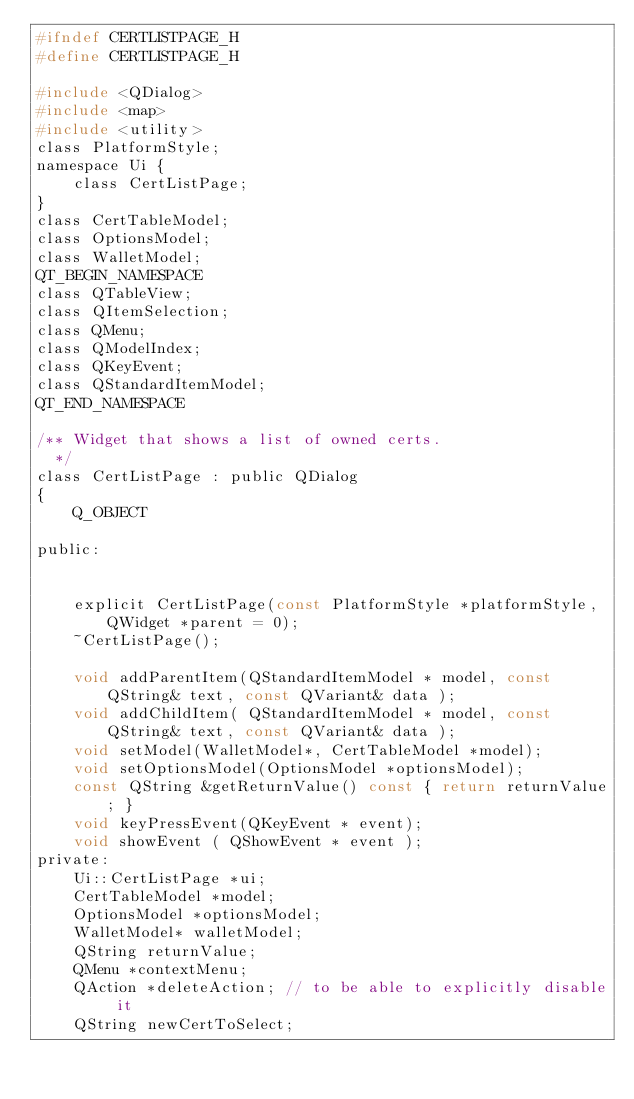<code> <loc_0><loc_0><loc_500><loc_500><_C_>#ifndef CERTLISTPAGE_H
#define CERTLISTPAGE_H

#include <QDialog>
#include <map>
#include <utility>
class PlatformStyle;
namespace Ui {
    class CertListPage;
}
class CertTableModel;
class OptionsModel;
class WalletModel;
QT_BEGIN_NAMESPACE
class QTableView;
class QItemSelection;
class QMenu;
class QModelIndex;
class QKeyEvent;
class QStandardItemModel;
QT_END_NAMESPACE

/** Widget that shows a list of owned certs.
  */
class CertListPage : public QDialog
{
    Q_OBJECT

public:
   

    explicit CertListPage(const PlatformStyle *platformStyle, QWidget *parent = 0);
    ~CertListPage();

    void addParentItem(QStandardItemModel * model, const QString& text, const QVariant& data );
    void addChildItem( QStandardItemModel * model, const QString& text, const QVariant& data );
    void setModel(WalletModel*, CertTableModel *model);
    void setOptionsModel(OptionsModel *optionsModel);
    const QString &getReturnValue() const { return returnValue; }
	void keyPressEvent(QKeyEvent * event);
	void showEvent ( QShowEvent * event );
private:
    Ui::CertListPage *ui;
    CertTableModel *model;
    OptionsModel *optionsModel;
	WalletModel* walletModel;
    QString returnValue;
    QMenu *contextMenu;
    QAction *deleteAction; // to be able to explicitly disable it
    QString newCertToSelect;</code> 